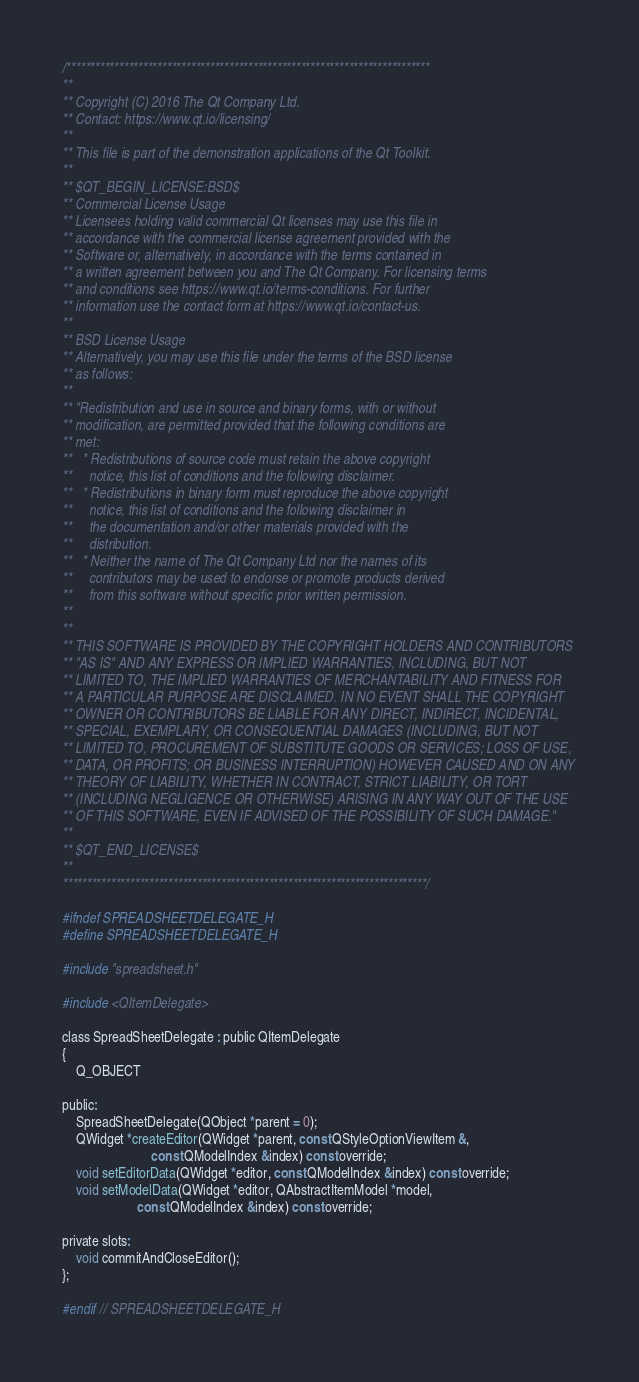<code> <loc_0><loc_0><loc_500><loc_500><_C_>/****************************************************************************
**
** Copyright (C) 2016 The Qt Company Ltd.
** Contact: https://www.qt.io/licensing/
**
** This file is part of the demonstration applications of the Qt Toolkit.
**
** $QT_BEGIN_LICENSE:BSD$
** Commercial License Usage
** Licensees holding valid commercial Qt licenses may use this file in
** accordance with the commercial license agreement provided with the
** Software or, alternatively, in accordance with the terms contained in
** a written agreement between you and The Qt Company. For licensing terms
** and conditions see https://www.qt.io/terms-conditions. For further
** information use the contact form at https://www.qt.io/contact-us.
**
** BSD License Usage
** Alternatively, you may use this file under the terms of the BSD license
** as follows:
**
** "Redistribution and use in source and binary forms, with or without
** modification, are permitted provided that the following conditions are
** met:
**   * Redistributions of source code must retain the above copyright
**     notice, this list of conditions and the following disclaimer.
**   * Redistributions in binary form must reproduce the above copyright
**     notice, this list of conditions and the following disclaimer in
**     the documentation and/or other materials provided with the
**     distribution.
**   * Neither the name of The Qt Company Ltd nor the names of its
**     contributors may be used to endorse or promote products derived
**     from this software without specific prior written permission.
**
**
** THIS SOFTWARE IS PROVIDED BY THE COPYRIGHT HOLDERS AND CONTRIBUTORS
** "AS IS" AND ANY EXPRESS OR IMPLIED WARRANTIES, INCLUDING, BUT NOT
** LIMITED TO, THE IMPLIED WARRANTIES OF MERCHANTABILITY AND FITNESS FOR
** A PARTICULAR PURPOSE ARE DISCLAIMED. IN NO EVENT SHALL THE COPYRIGHT
** OWNER OR CONTRIBUTORS BE LIABLE FOR ANY DIRECT, INDIRECT, INCIDENTAL,
** SPECIAL, EXEMPLARY, OR CONSEQUENTIAL DAMAGES (INCLUDING, BUT NOT
** LIMITED TO, PROCUREMENT OF SUBSTITUTE GOODS OR SERVICES; LOSS OF USE,
** DATA, OR PROFITS; OR BUSINESS INTERRUPTION) HOWEVER CAUSED AND ON ANY
** THEORY OF LIABILITY, WHETHER IN CONTRACT, STRICT LIABILITY, OR TORT
** (INCLUDING NEGLIGENCE OR OTHERWISE) ARISING IN ANY WAY OUT OF THE USE
** OF THIS SOFTWARE, EVEN IF ADVISED OF THE POSSIBILITY OF SUCH DAMAGE."
**
** $QT_END_LICENSE$
**
****************************************************************************/

#ifndef SPREADSHEETDELEGATE_H
#define SPREADSHEETDELEGATE_H

#include "spreadsheet.h"

#include <QItemDelegate>

class SpreadSheetDelegate : public QItemDelegate
{
    Q_OBJECT

public:
    SpreadSheetDelegate(QObject *parent = 0);
    QWidget *createEditor(QWidget *parent, const QStyleOptionViewItem &,
                          const QModelIndex &index) const override;
    void setEditorData(QWidget *editor, const QModelIndex &index) const override;
    void setModelData(QWidget *editor, QAbstractItemModel *model,
                      const QModelIndex &index) const override;

private slots:
    void commitAndCloseEditor();
};

#endif // SPREADSHEETDELEGATE_H

</code> 